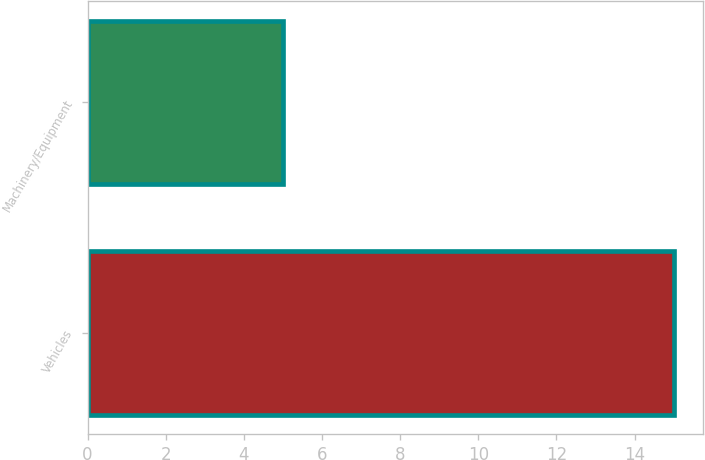<chart> <loc_0><loc_0><loc_500><loc_500><bar_chart><fcel>Vehicles<fcel>Machinery/Equipment<nl><fcel>15<fcel>5<nl></chart> 